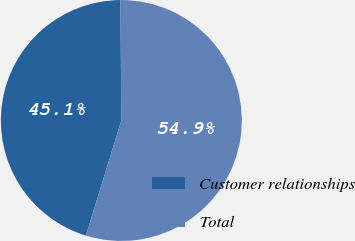Convert chart to OTSL. <chart><loc_0><loc_0><loc_500><loc_500><pie_chart><fcel>Customer relationships<fcel>Total<nl><fcel>45.14%<fcel>54.86%<nl></chart> 